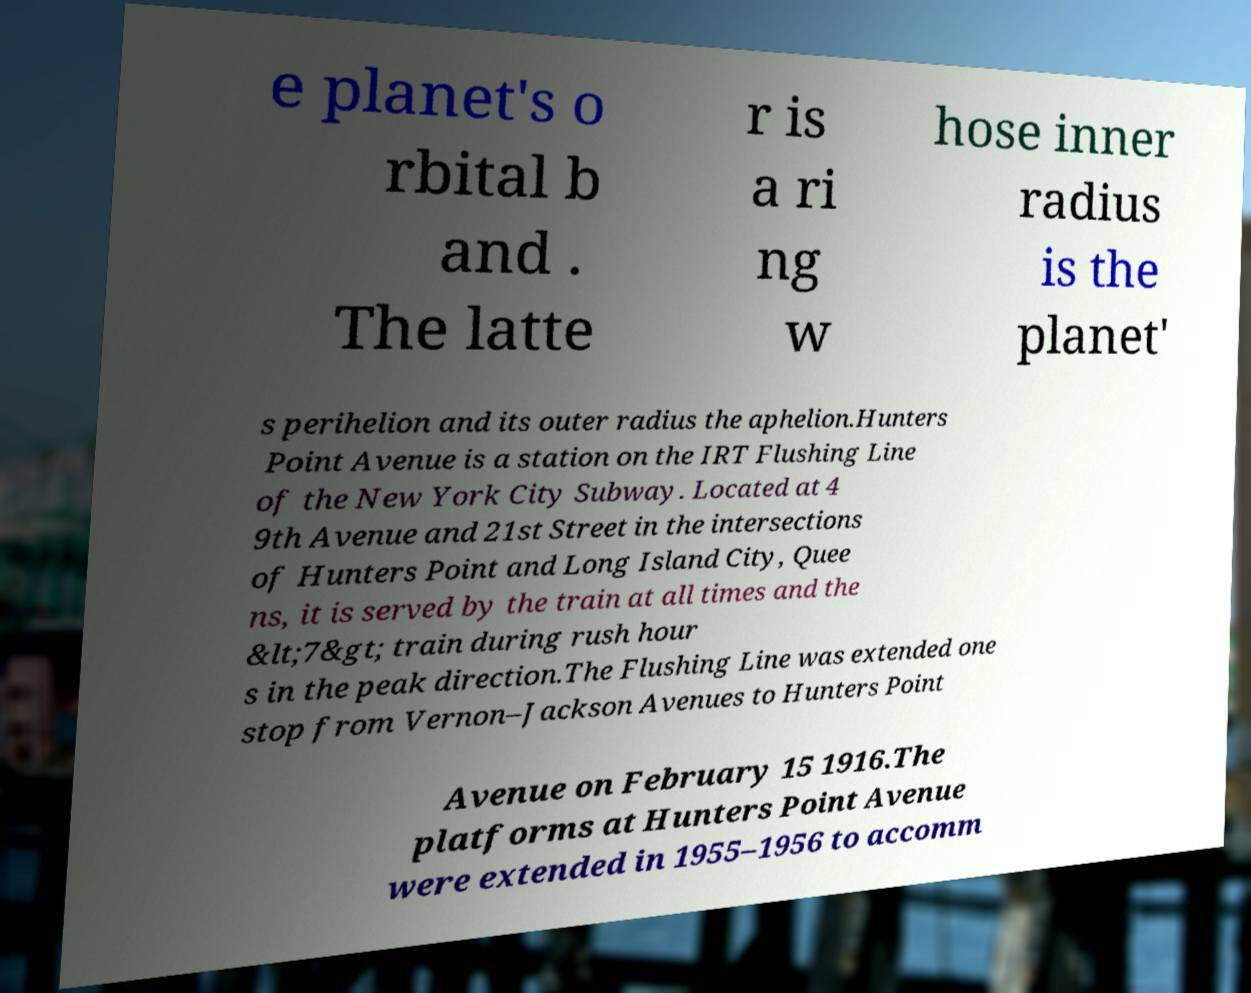There's text embedded in this image that I need extracted. Can you transcribe it verbatim? e planet's o rbital b and . The latte r is a ri ng w hose inner radius is the planet' s perihelion and its outer radius the aphelion.Hunters Point Avenue is a station on the IRT Flushing Line of the New York City Subway. Located at 4 9th Avenue and 21st Street in the intersections of Hunters Point and Long Island City, Quee ns, it is served by the train at all times and the &lt;7&gt; train during rush hour s in the peak direction.The Flushing Line was extended one stop from Vernon–Jackson Avenues to Hunters Point Avenue on February 15 1916.The platforms at Hunters Point Avenue were extended in 1955–1956 to accomm 